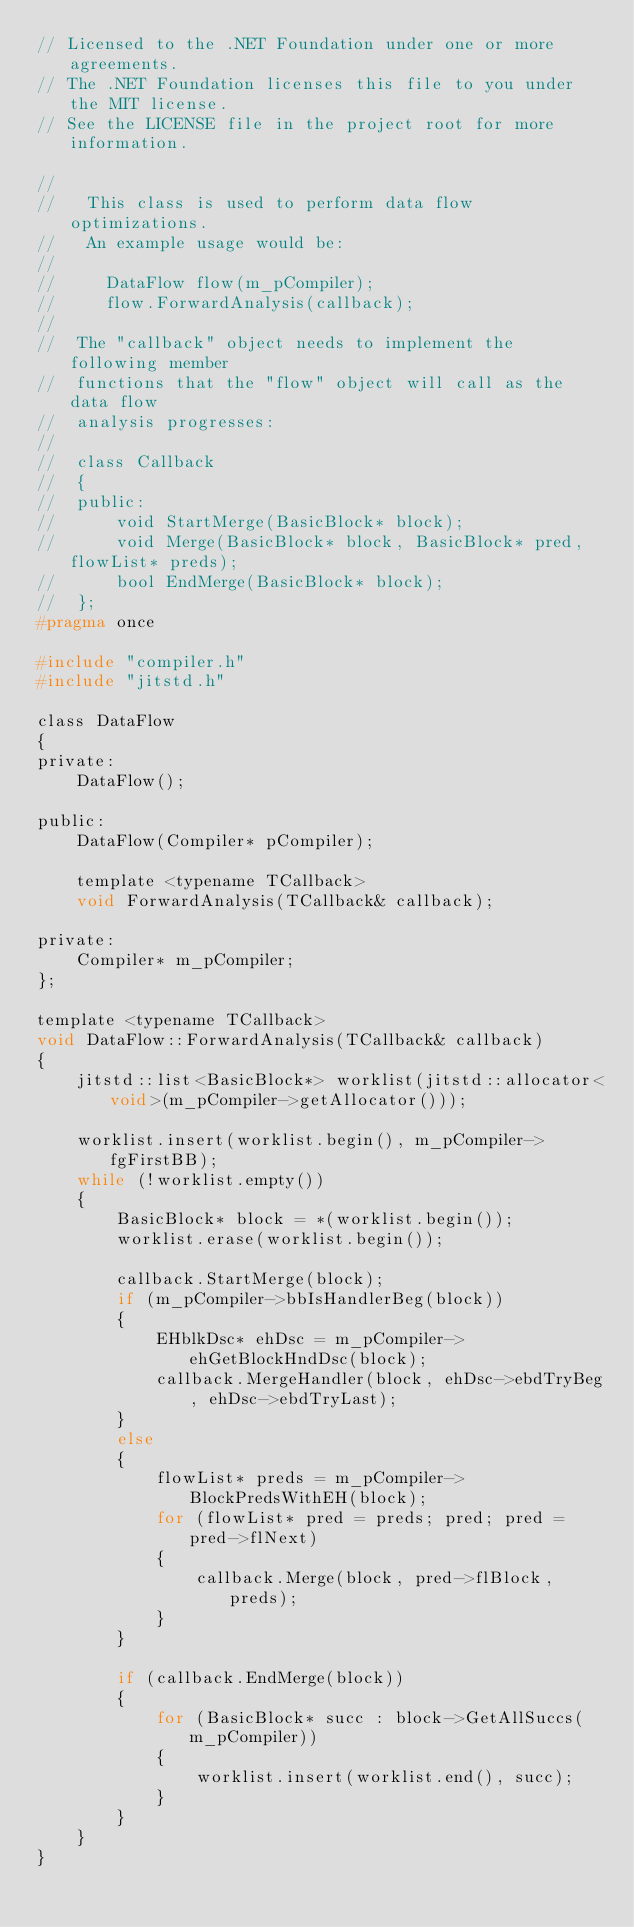<code> <loc_0><loc_0><loc_500><loc_500><_C_>// Licensed to the .NET Foundation under one or more agreements.
// The .NET Foundation licenses this file to you under the MIT license.
// See the LICENSE file in the project root for more information.

//
//   This class is used to perform data flow optimizations.
//   An example usage would be:
//
//     DataFlow flow(m_pCompiler);
//     flow.ForwardAnalysis(callback);
//
//  The "callback" object needs to implement the following member
//  functions that the "flow" object will call as the data flow
//  analysis progresses:
//
//  class Callback
//  {
//  public:
//      void StartMerge(BasicBlock* block);
//      void Merge(BasicBlock* block, BasicBlock* pred, flowList* preds);
//      bool EndMerge(BasicBlock* block);
//  };
#pragma once

#include "compiler.h"
#include "jitstd.h"

class DataFlow
{
private:
    DataFlow();

public:
    DataFlow(Compiler* pCompiler);

    template <typename TCallback>
    void ForwardAnalysis(TCallback& callback);

private:
    Compiler* m_pCompiler;
};

template <typename TCallback>
void DataFlow::ForwardAnalysis(TCallback& callback)
{
    jitstd::list<BasicBlock*> worklist(jitstd::allocator<void>(m_pCompiler->getAllocator()));

    worklist.insert(worklist.begin(), m_pCompiler->fgFirstBB);
    while (!worklist.empty())
    {
        BasicBlock* block = *(worklist.begin());
        worklist.erase(worklist.begin());

        callback.StartMerge(block);
        if (m_pCompiler->bbIsHandlerBeg(block))
        {
            EHblkDsc* ehDsc = m_pCompiler->ehGetBlockHndDsc(block);
            callback.MergeHandler(block, ehDsc->ebdTryBeg, ehDsc->ebdTryLast);
        }
        else
        {
            flowList* preds = m_pCompiler->BlockPredsWithEH(block);
            for (flowList* pred = preds; pred; pred = pred->flNext)
            {
                callback.Merge(block, pred->flBlock, preds);
            }
        }

        if (callback.EndMerge(block))
        {
            for (BasicBlock* succ : block->GetAllSuccs(m_pCompiler))
            {
                worklist.insert(worklist.end(), succ);
            }
        }
    }
}
</code> 